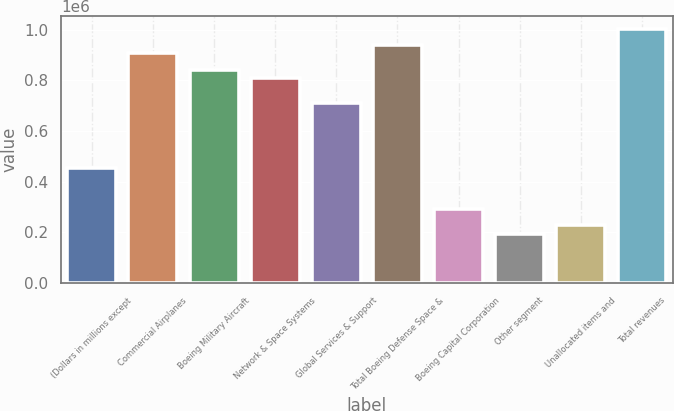<chart> <loc_0><loc_0><loc_500><loc_500><bar_chart><fcel>(Dollars in millions except<fcel>Commercial Airplanes<fcel>Boeing Military Aircraft<fcel>Network & Space Systems<fcel>Global Services & Support<fcel>Total Boeing Defense Space &<fcel>Boeing Capital Corporation<fcel>Other segment<fcel>Unallocated items and<fcel>Total revenues<nl><fcel>453403<fcel>906805<fcel>842033<fcel>809648<fcel>712490<fcel>939191<fcel>291474<fcel>194317<fcel>226702<fcel>1.00396e+06<nl></chart> 